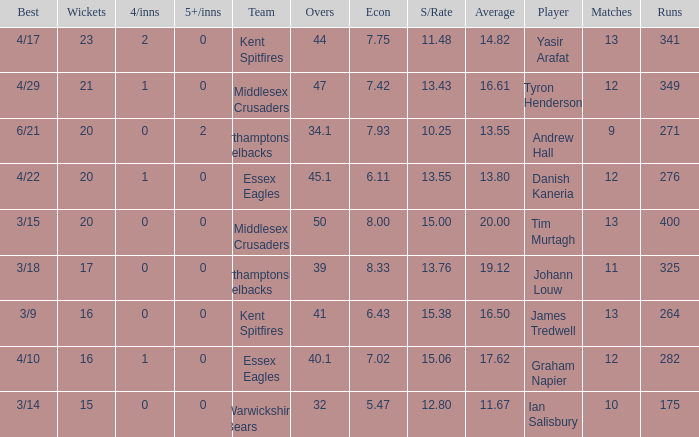Name the most 4/inns 2.0. 